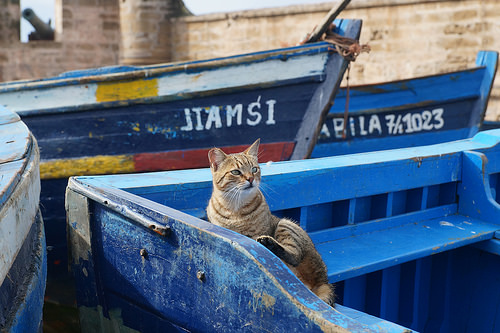<image>
Is there a cat on the bench? Yes. Looking at the image, I can see the cat is positioned on top of the bench, with the bench providing support. Is there a cat in front of the boat? Yes. The cat is positioned in front of the boat, appearing closer to the camera viewpoint. 